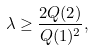<formula> <loc_0><loc_0><loc_500><loc_500>\lambda \geq \frac { 2 Q ( 2 ) } { Q ( 1 ) ^ { 2 } } ,</formula> 